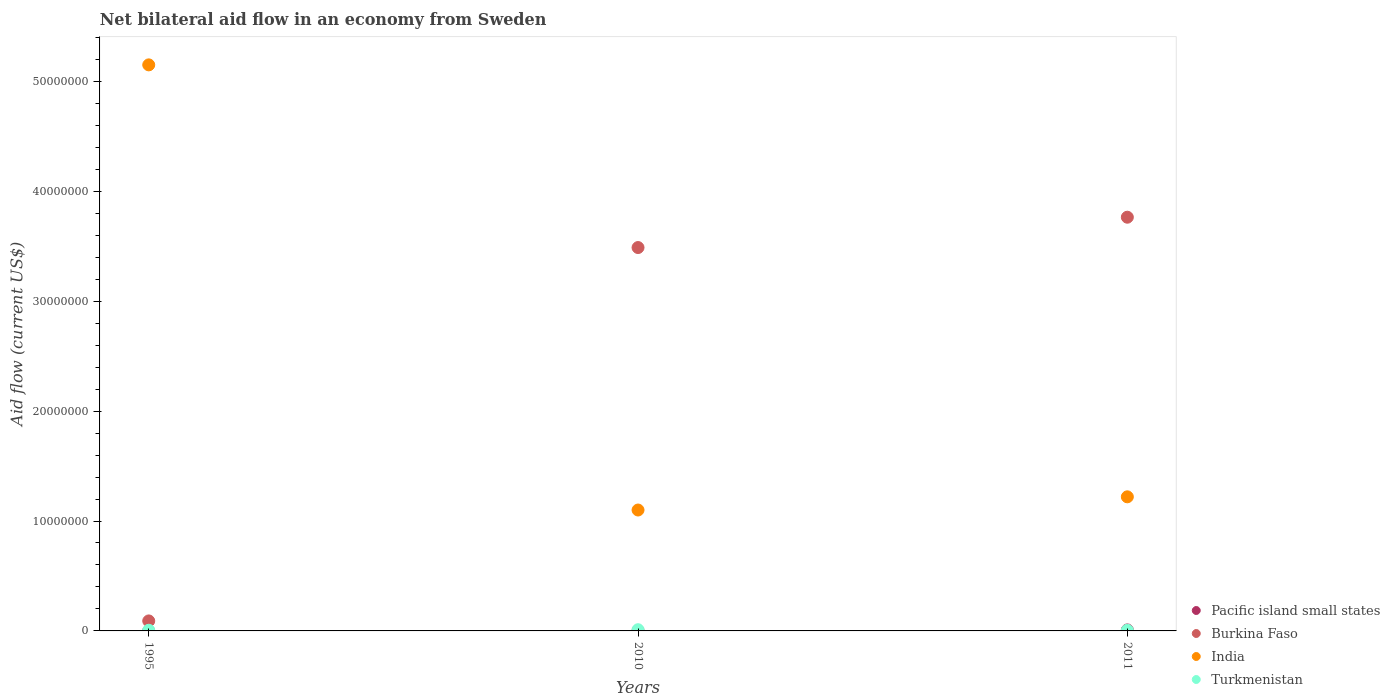How many different coloured dotlines are there?
Provide a succinct answer. 4. What is the net bilateral aid flow in Turkmenistan in 1995?
Make the answer very short. 6.00e+04. Across all years, what is the maximum net bilateral aid flow in Burkina Faso?
Give a very brief answer. 3.76e+07. Across all years, what is the minimum net bilateral aid flow in Turkmenistan?
Your response must be concise. 6.00e+04. In which year was the net bilateral aid flow in Pacific island small states maximum?
Give a very brief answer. 2011. In which year was the net bilateral aid flow in Turkmenistan minimum?
Keep it short and to the point. 1995. What is the difference between the net bilateral aid flow in Burkina Faso in 1995 and that in 2011?
Keep it short and to the point. -3.67e+07. What is the difference between the net bilateral aid flow in India in 2011 and the net bilateral aid flow in Pacific island small states in 1995?
Offer a very short reply. 1.22e+07. What is the average net bilateral aid flow in Turkmenistan per year?
Ensure brevity in your answer.  7.67e+04. In the year 2011, what is the difference between the net bilateral aid flow in Turkmenistan and net bilateral aid flow in Pacific island small states?
Provide a short and direct response. -3.00e+04. What is the ratio of the net bilateral aid flow in Burkina Faso in 1995 to that in 2011?
Give a very brief answer. 0.02. Is the difference between the net bilateral aid flow in Turkmenistan in 2010 and 2011 greater than the difference between the net bilateral aid flow in Pacific island small states in 2010 and 2011?
Give a very brief answer. Yes. What is the difference between the highest and the second highest net bilateral aid flow in Pacific island small states?
Offer a very short reply. 7.00e+04. What is the difference between the highest and the lowest net bilateral aid flow in Burkina Faso?
Offer a very short reply. 3.67e+07. Is the sum of the net bilateral aid flow in Pacific island small states in 1995 and 2010 greater than the maximum net bilateral aid flow in Turkmenistan across all years?
Provide a short and direct response. No. Does the net bilateral aid flow in Burkina Faso monotonically increase over the years?
Your response must be concise. Yes. Is the net bilateral aid flow in Turkmenistan strictly greater than the net bilateral aid flow in Burkina Faso over the years?
Ensure brevity in your answer.  No. How many dotlines are there?
Make the answer very short. 4. How many years are there in the graph?
Provide a short and direct response. 3. Are the values on the major ticks of Y-axis written in scientific E-notation?
Your response must be concise. No. Does the graph contain any zero values?
Give a very brief answer. No. How many legend labels are there?
Your answer should be very brief. 4. How are the legend labels stacked?
Provide a succinct answer. Vertical. What is the title of the graph?
Your answer should be compact. Net bilateral aid flow in an economy from Sweden. What is the label or title of the X-axis?
Your answer should be very brief. Years. What is the label or title of the Y-axis?
Offer a terse response. Aid flow (current US$). What is the Aid flow (current US$) in Pacific island small states in 1995?
Offer a terse response. 10000. What is the Aid flow (current US$) in Burkina Faso in 1995?
Make the answer very short. 9.10e+05. What is the Aid flow (current US$) of India in 1995?
Offer a very short reply. 5.15e+07. What is the Aid flow (current US$) in Turkmenistan in 1995?
Your answer should be very brief. 6.00e+04. What is the Aid flow (current US$) of Pacific island small states in 2010?
Give a very brief answer. 2.00e+04. What is the Aid flow (current US$) of Burkina Faso in 2010?
Provide a short and direct response. 3.49e+07. What is the Aid flow (current US$) of India in 2010?
Offer a very short reply. 1.10e+07. What is the Aid flow (current US$) of Turkmenistan in 2010?
Keep it short and to the point. 1.10e+05. What is the Aid flow (current US$) of Pacific island small states in 2011?
Provide a succinct answer. 9.00e+04. What is the Aid flow (current US$) in Burkina Faso in 2011?
Your answer should be compact. 3.76e+07. What is the Aid flow (current US$) in India in 2011?
Your answer should be very brief. 1.22e+07. Across all years, what is the maximum Aid flow (current US$) in Pacific island small states?
Keep it short and to the point. 9.00e+04. Across all years, what is the maximum Aid flow (current US$) in Burkina Faso?
Provide a short and direct response. 3.76e+07. Across all years, what is the maximum Aid flow (current US$) in India?
Your response must be concise. 5.15e+07. Across all years, what is the maximum Aid flow (current US$) in Turkmenistan?
Your answer should be very brief. 1.10e+05. Across all years, what is the minimum Aid flow (current US$) of Pacific island small states?
Offer a terse response. 10000. Across all years, what is the minimum Aid flow (current US$) of Burkina Faso?
Offer a terse response. 9.10e+05. Across all years, what is the minimum Aid flow (current US$) of India?
Keep it short and to the point. 1.10e+07. What is the total Aid flow (current US$) of Pacific island small states in the graph?
Your answer should be very brief. 1.20e+05. What is the total Aid flow (current US$) of Burkina Faso in the graph?
Keep it short and to the point. 7.34e+07. What is the total Aid flow (current US$) in India in the graph?
Provide a succinct answer. 7.47e+07. What is the difference between the Aid flow (current US$) in Burkina Faso in 1995 and that in 2010?
Offer a very short reply. -3.40e+07. What is the difference between the Aid flow (current US$) in India in 1995 and that in 2010?
Ensure brevity in your answer.  4.05e+07. What is the difference between the Aid flow (current US$) in Turkmenistan in 1995 and that in 2010?
Your answer should be compact. -5.00e+04. What is the difference between the Aid flow (current US$) in Burkina Faso in 1995 and that in 2011?
Your response must be concise. -3.67e+07. What is the difference between the Aid flow (current US$) in India in 1995 and that in 2011?
Provide a succinct answer. 3.93e+07. What is the difference between the Aid flow (current US$) of Turkmenistan in 1995 and that in 2011?
Offer a terse response. 0. What is the difference between the Aid flow (current US$) in Pacific island small states in 2010 and that in 2011?
Provide a short and direct response. -7.00e+04. What is the difference between the Aid flow (current US$) in Burkina Faso in 2010 and that in 2011?
Make the answer very short. -2.76e+06. What is the difference between the Aid flow (current US$) of India in 2010 and that in 2011?
Offer a very short reply. -1.20e+06. What is the difference between the Aid flow (current US$) in Pacific island small states in 1995 and the Aid flow (current US$) in Burkina Faso in 2010?
Your answer should be compact. -3.49e+07. What is the difference between the Aid flow (current US$) of Pacific island small states in 1995 and the Aid flow (current US$) of India in 2010?
Provide a short and direct response. -1.10e+07. What is the difference between the Aid flow (current US$) in Burkina Faso in 1995 and the Aid flow (current US$) in India in 2010?
Keep it short and to the point. -1.01e+07. What is the difference between the Aid flow (current US$) of India in 1995 and the Aid flow (current US$) of Turkmenistan in 2010?
Give a very brief answer. 5.14e+07. What is the difference between the Aid flow (current US$) of Pacific island small states in 1995 and the Aid flow (current US$) of Burkina Faso in 2011?
Provide a succinct answer. -3.76e+07. What is the difference between the Aid flow (current US$) of Pacific island small states in 1995 and the Aid flow (current US$) of India in 2011?
Provide a short and direct response. -1.22e+07. What is the difference between the Aid flow (current US$) of Pacific island small states in 1995 and the Aid flow (current US$) of Turkmenistan in 2011?
Ensure brevity in your answer.  -5.00e+04. What is the difference between the Aid flow (current US$) in Burkina Faso in 1995 and the Aid flow (current US$) in India in 2011?
Offer a very short reply. -1.13e+07. What is the difference between the Aid flow (current US$) of Burkina Faso in 1995 and the Aid flow (current US$) of Turkmenistan in 2011?
Provide a short and direct response. 8.50e+05. What is the difference between the Aid flow (current US$) of India in 1995 and the Aid flow (current US$) of Turkmenistan in 2011?
Ensure brevity in your answer.  5.14e+07. What is the difference between the Aid flow (current US$) of Pacific island small states in 2010 and the Aid flow (current US$) of Burkina Faso in 2011?
Provide a succinct answer. -3.76e+07. What is the difference between the Aid flow (current US$) in Pacific island small states in 2010 and the Aid flow (current US$) in India in 2011?
Make the answer very short. -1.22e+07. What is the difference between the Aid flow (current US$) of Burkina Faso in 2010 and the Aid flow (current US$) of India in 2011?
Your answer should be very brief. 2.27e+07. What is the difference between the Aid flow (current US$) of Burkina Faso in 2010 and the Aid flow (current US$) of Turkmenistan in 2011?
Give a very brief answer. 3.48e+07. What is the difference between the Aid flow (current US$) in India in 2010 and the Aid flow (current US$) in Turkmenistan in 2011?
Give a very brief answer. 1.09e+07. What is the average Aid flow (current US$) of Pacific island small states per year?
Provide a succinct answer. 4.00e+04. What is the average Aid flow (current US$) in Burkina Faso per year?
Provide a succinct answer. 2.45e+07. What is the average Aid flow (current US$) in India per year?
Provide a succinct answer. 2.49e+07. What is the average Aid flow (current US$) of Turkmenistan per year?
Give a very brief answer. 7.67e+04. In the year 1995, what is the difference between the Aid flow (current US$) in Pacific island small states and Aid flow (current US$) in Burkina Faso?
Provide a short and direct response. -9.00e+05. In the year 1995, what is the difference between the Aid flow (current US$) in Pacific island small states and Aid flow (current US$) in India?
Provide a succinct answer. -5.15e+07. In the year 1995, what is the difference between the Aid flow (current US$) in Burkina Faso and Aid flow (current US$) in India?
Ensure brevity in your answer.  -5.06e+07. In the year 1995, what is the difference between the Aid flow (current US$) of Burkina Faso and Aid flow (current US$) of Turkmenistan?
Give a very brief answer. 8.50e+05. In the year 1995, what is the difference between the Aid flow (current US$) in India and Aid flow (current US$) in Turkmenistan?
Make the answer very short. 5.14e+07. In the year 2010, what is the difference between the Aid flow (current US$) of Pacific island small states and Aid flow (current US$) of Burkina Faso?
Make the answer very short. -3.49e+07. In the year 2010, what is the difference between the Aid flow (current US$) of Pacific island small states and Aid flow (current US$) of India?
Your answer should be compact. -1.10e+07. In the year 2010, what is the difference between the Aid flow (current US$) of Pacific island small states and Aid flow (current US$) of Turkmenistan?
Your response must be concise. -9.00e+04. In the year 2010, what is the difference between the Aid flow (current US$) of Burkina Faso and Aid flow (current US$) of India?
Provide a short and direct response. 2.39e+07. In the year 2010, what is the difference between the Aid flow (current US$) in Burkina Faso and Aid flow (current US$) in Turkmenistan?
Provide a short and direct response. 3.48e+07. In the year 2010, what is the difference between the Aid flow (current US$) of India and Aid flow (current US$) of Turkmenistan?
Offer a terse response. 1.09e+07. In the year 2011, what is the difference between the Aid flow (current US$) in Pacific island small states and Aid flow (current US$) in Burkina Faso?
Ensure brevity in your answer.  -3.76e+07. In the year 2011, what is the difference between the Aid flow (current US$) of Pacific island small states and Aid flow (current US$) of India?
Your answer should be very brief. -1.21e+07. In the year 2011, what is the difference between the Aid flow (current US$) in Pacific island small states and Aid flow (current US$) in Turkmenistan?
Your answer should be very brief. 3.00e+04. In the year 2011, what is the difference between the Aid flow (current US$) of Burkina Faso and Aid flow (current US$) of India?
Your answer should be compact. 2.54e+07. In the year 2011, what is the difference between the Aid flow (current US$) of Burkina Faso and Aid flow (current US$) of Turkmenistan?
Make the answer very short. 3.76e+07. In the year 2011, what is the difference between the Aid flow (current US$) in India and Aid flow (current US$) in Turkmenistan?
Provide a short and direct response. 1.21e+07. What is the ratio of the Aid flow (current US$) in Pacific island small states in 1995 to that in 2010?
Offer a very short reply. 0.5. What is the ratio of the Aid flow (current US$) of Burkina Faso in 1995 to that in 2010?
Offer a terse response. 0.03. What is the ratio of the Aid flow (current US$) of India in 1995 to that in 2010?
Offer a very short reply. 4.68. What is the ratio of the Aid flow (current US$) of Turkmenistan in 1995 to that in 2010?
Your answer should be compact. 0.55. What is the ratio of the Aid flow (current US$) in Burkina Faso in 1995 to that in 2011?
Make the answer very short. 0.02. What is the ratio of the Aid flow (current US$) in India in 1995 to that in 2011?
Offer a very short reply. 4.22. What is the ratio of the Aid flow (current US$) in Pacific island small states in 2010 to that in 2011?
Provide a succinct answer. 0.22. What is the ratio of the Aid flow (current US$) in Burkina Faso in 2010 to that in 2011?
Keep it short and to the point. 0.93. What is the ratio of the Aid flow (current US$) of India in 2010 to that in 2011?
Offer a very short reply. 0.9. What is the ratio of the Aid flow (current US$) of Turkmenistan in 2010 to that in 2011?
Provide a succinct answer. 1.83. What is the difference between the highest and the second highest Aid flow (current US$) of Burkina Faso?
Your answer should be very brief. 2.76e+06. What is the difference between the highest and the second highest Aid flow (current US$) in India?
Provide a short and direct response. 3.93e+07. What is the difference between the highest and the second highest Aid flow (current US$) of Turkmenistan?
Your answer should be compact. 5.00e+04. What is the difference between the highest and the lowest Aid flow (current US$) in Pacific island small states?
Give a very brief answer. 8.00e+04. What is the difference between the highest and the lowest Aid flow (current US$) in Burkina Faso?
Keep it short and to the point. 3.67e+07. What is the difference between the highest and the lowest Aid flow (current US$) of India?
Give a very brief answer. 4.05e+07. What is the difference between the highest and the lowest Aid flow (current US$) in Turkmenistan?
Ensure brevity in your answer.  5.00e+04. 